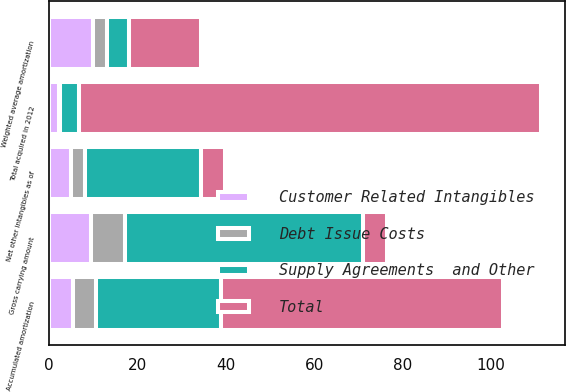<chart> <loc_0><loc_0><loc_500><loc_500><stacked_bar_chart><ecel><fcel>Gross carrying amount<fcel>Accumulated amortization<fcel>Net other intangibles as of<fcel>Weighted average amortization<fcel>Total acquired in 2012<nl><fcel>Customer Related Intangibles<fcel>9.5<fcel>5.5<fcel>5<fcel>10<fcel>2.3<nl><fcel>Supply Agreements  and Other<fcel>53.8<fcel>28.2<fcel>26.2<fcel>5<fcel>4.4<nl><fcel>Debt Issue Costs<fcel>7.7<fcel>5.2<fcel>3.1<fcel>3.2<fcel>0.1<nl><fcel>Total<fcel>5.5<fcel>63.9<fcel>5.5<fcel>16.1<fcel>104.5<nl></chart> 